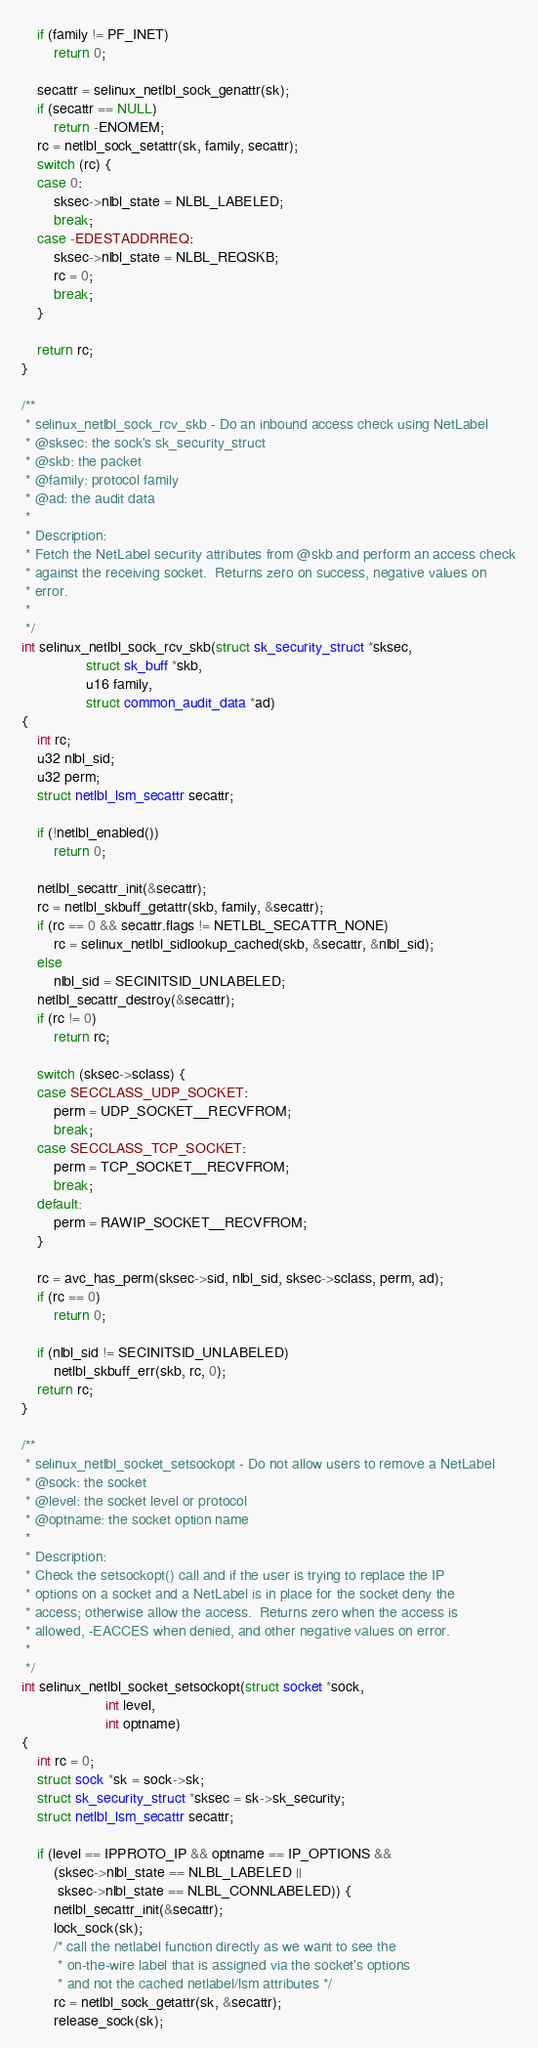<code> <loc_0><loc_0><loc_500><loc_500><_C_>	if (family != PF_INET)
		return 0;

	secattr = selinux_netlbl_sock_genattr(sk);
	if (secattr == NULL)
		return -ENOMEM;
	rc = netlbl_sock_setattr(sk, family, secattr);
	switch (rc) {
	case 0:
		sksec->nlbl_state = NLBL_LABELED;
		break;
	case -EDESTADDRREQ:
		sksec->nlbl_state = NLBL_REQSKB;
		rc = 0;
		break;
	}

	return rc;
}

/**
 * selinux_netlbl_sock_rcv_skb - Do an inbound access check using NetLabel
 * @sksec: the sock's sk_security_struct
 * @skb: the packet
 * @family: protocol family
 * @ad: the audit data
 *
 * Description:
 * Fetch the NetLabel security attributes from @skb and perform an access check
 * against the receiving socket.  Returns zero on success, negative values on
 * error.
 *
 */
int selinux_netlbl_sock_rcv_skb(struct sk_security_struct *sksec,
				struct sk_buff *skb,
				u16 family,
				struct common_audit_data *ad)
{
	int rc;
	u32 nlbl_sid;
	u32 perm;
	struct netlbl_lsm_secattr secattr;

	if (!netlbl_enabled())
		return 0;

	netlbl_secattr_init(&secattr);
	rc = netlbl_skbuff_getattr(skb, family, &secattr);
	if (rc == 0 && secattr.flags != NETLBL_SECATTR_NONE)
		rc = selinux_netlbl_sidlookup_cached(skb, &secattr, &nlbl_sid);
	else
		nlbl_sid = SECINITSID_UNLABELED;
	netlbl_secattr_destroy(&secattr);
	if (rc != 0)
		return rc;

	switch (sksec->sclass) {
	case SECCLASS_UDP_SOCKET:
		perm = UDP_SOCKET__RECVFROM;
		break;
	case SECCLASS_TCP_SOCKET:
		perm = TCP_SOCKET__RECVFROM;
		break;
	default:
		perm = RAWIP_SOCKET__RECVFROM;
	}

	rc = avc_has_perm(sksec->sid, nlbl_sid, sksec->sclass, perm, ad);
	if (rc == 0)
		return 0;

	if (nlbl_sid != SECINITSID_UNLABELED)
		netlbl_skbuff_err(skb, rc, 0);
	return rc;
}

/**
 * selinux_netlbl_socket_setsockopt - Do not allow users to remove a NetLabel
 * @sock: the socket
 * @level: the socket level or protocol
 * @optname: the socket option name
 *
 * Description:
 * Check the setsockopt() call and if the user is trying to replace the IP
 * options on a socket and a NetLabel is in place for the socket deny the
 * access; otherwise allow the access.  Returns zero when the access is
 * allowed, -EACCES when denied, and other negative values on error.
 *
 */
int selinux_netlbl_socket_setsockopt(struct socket *sock,
				     int level,
				     int optname)
{
	int rc = 0;
	struct sock *sk = sock->sk;
	struct sk_security_struct *sksec = sk->sk_security;
	struct netlbl_lsm_secattr secattr;

	if (level == IPPROTO_IP && optname == IP_OPTIONS &&
	    (sksec->nlbl_state == NLBL_LABELED ||
	     sksec->nlbl_state == NLBL_CONNLABELED)) {
		netlbl_secattr_init(&secattr);
		lock_sock(sk);
		/* call the netlabel function directly as we want to see the
		 * on-the-wire label that is assigned via the socket's options
		 * and not the cached netlabel/lsm attributes */
		rc = netlbl_sock_getattr(sk, &secattr);
		release_sock(sk);</code> 